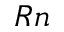Convert formula to latex. <formula><loc_0><loc_0><loc_500><loc_500>_ { R n }</formula> 